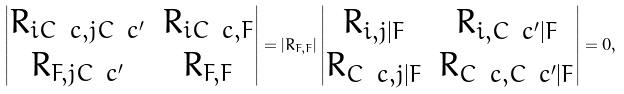Convert formula to latex. <formula><loc_0><loc_0><loc_500><loc_500>\begin{vmatrix} R _ { i C \ c , j C \ c ^ { \prime } } & R _ { i C \ c , F } \\ R _ { F , j C \ c ^ { \prime } } & R _ { F , F } \end{vmatrix} = \left | R _ { F , F } \right | \begin{vmatrix} R _ { i , j | F } & R _ { i , C \ c ^ { \prime } | F } \\ R _ { C \ c , j | F } & R _ { C \ c , C \ c ^ { \prime } | F } \end{vmatrix} = 0 ,</formula> 